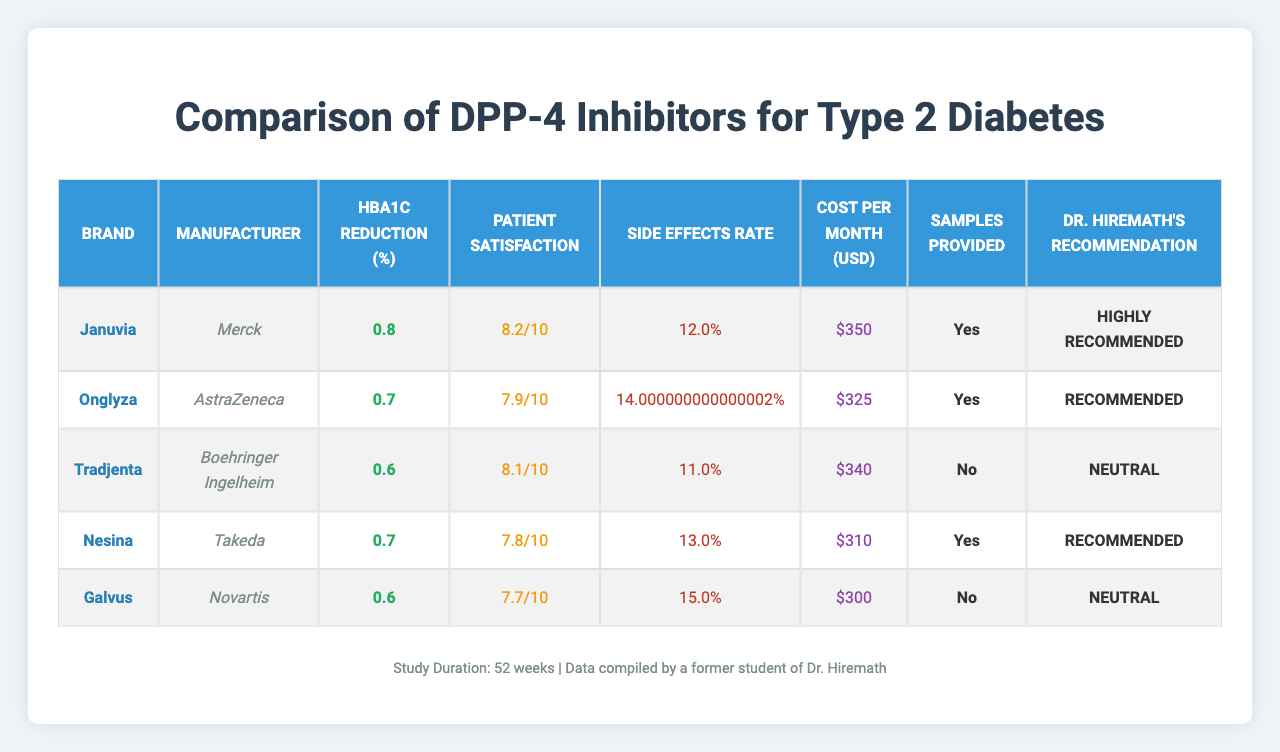What is the efficacy rate of Januvia? The efficacy rate for Januvia is provided directly in the table under the "HbA1c Reduction (%)" column. According to the data, it is 0.8%.
Answer: 0.8% Which drug has the highest patient satisfaction rating? By looking at the "Patient Satisfaction" column in the table, comparing the values shows that Januvia has the highest rating at 8.2/10.
Answer: 8.2/10 Is there a drug that has side effects rate less than 12%? Checking the "Side Effects Rate" column, we see that only Tradjenta has a side effects rate of 11%, which is less than 12%.
Answer: Yes What is the average side effects rate of the drugs listed? To find the average, add all the side effects rates: (12% + 14% + 11% + 13% + 15%) = 65%. Divide this sum by the number of drugs (5): 65% / 5 = 13%.
Answer: 13% How many brands provide samples according to the table? The "Samples Provided" column indicates which brands provide samples. Counting the "Yes" entries, we see that 3 brands provide samples: Januvia, Onglyza, and Nesina.
Answer: 3 What is the difference in monthly cost between the most and least expensive drug? The highest monthly cost is for Januvia at $350, and the lowest is for Galvus at $300. The difference is calculated as $350 - $300 = $50.
Answer: $50 Are there any drugs that have both high efficacy and high patient satisfaction? Evaluating the "HbA1c Reduction (%)" and "Patient Satisfaction" together, Januvia has both high efficacy (0.8%) and the highest satisfaction (8.2), indicating it meets both criteria.
Answer: Yes Which drug has the lowest recommendation from Dr. Hiremath? The "Dr. Hiremath's Recommendation" column shows that Galvus and Tradjenta both have the label "Neutral," which is the lowest rating.
Answer: Galvus and Tradjenta What is the cost of the drug with the highest side effects rate? The drug with the highest side effects rate is Galvus at 15%, and according to the "Cost per Month (USD)" column, its cost is $300.
Answer: $300 What is the average efficacy rate of all listed drugs? Adding the efficacy rates: (0.8 + 0.7 + 0.6 + 0.7 + 0.6) = 3.4%. To find the average, divide by the number of drugs (5): 3.4% / 5 = 0.68%.
Answer: 0.68% 